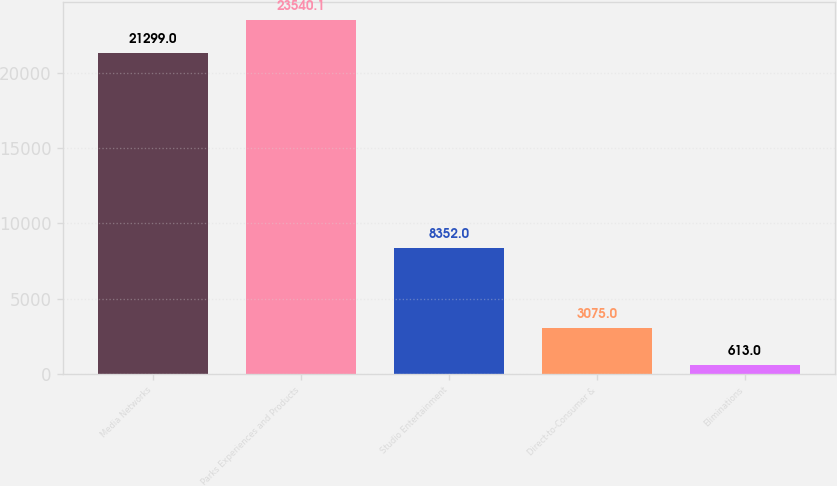Convert chart. <chart><loc_0><loc_0><loc_500><loc_500><bar_chart><fcel>Media Networks<fcel>Parks Experiences and Products<fcel>Studio Entertainment<fcel>Direct-to-Consumer &<fcel>Eliminations<nl><fcel>21299<fcel>23540.1<fcel>8352<fcel>3075<fcel>613<nl></chart> 